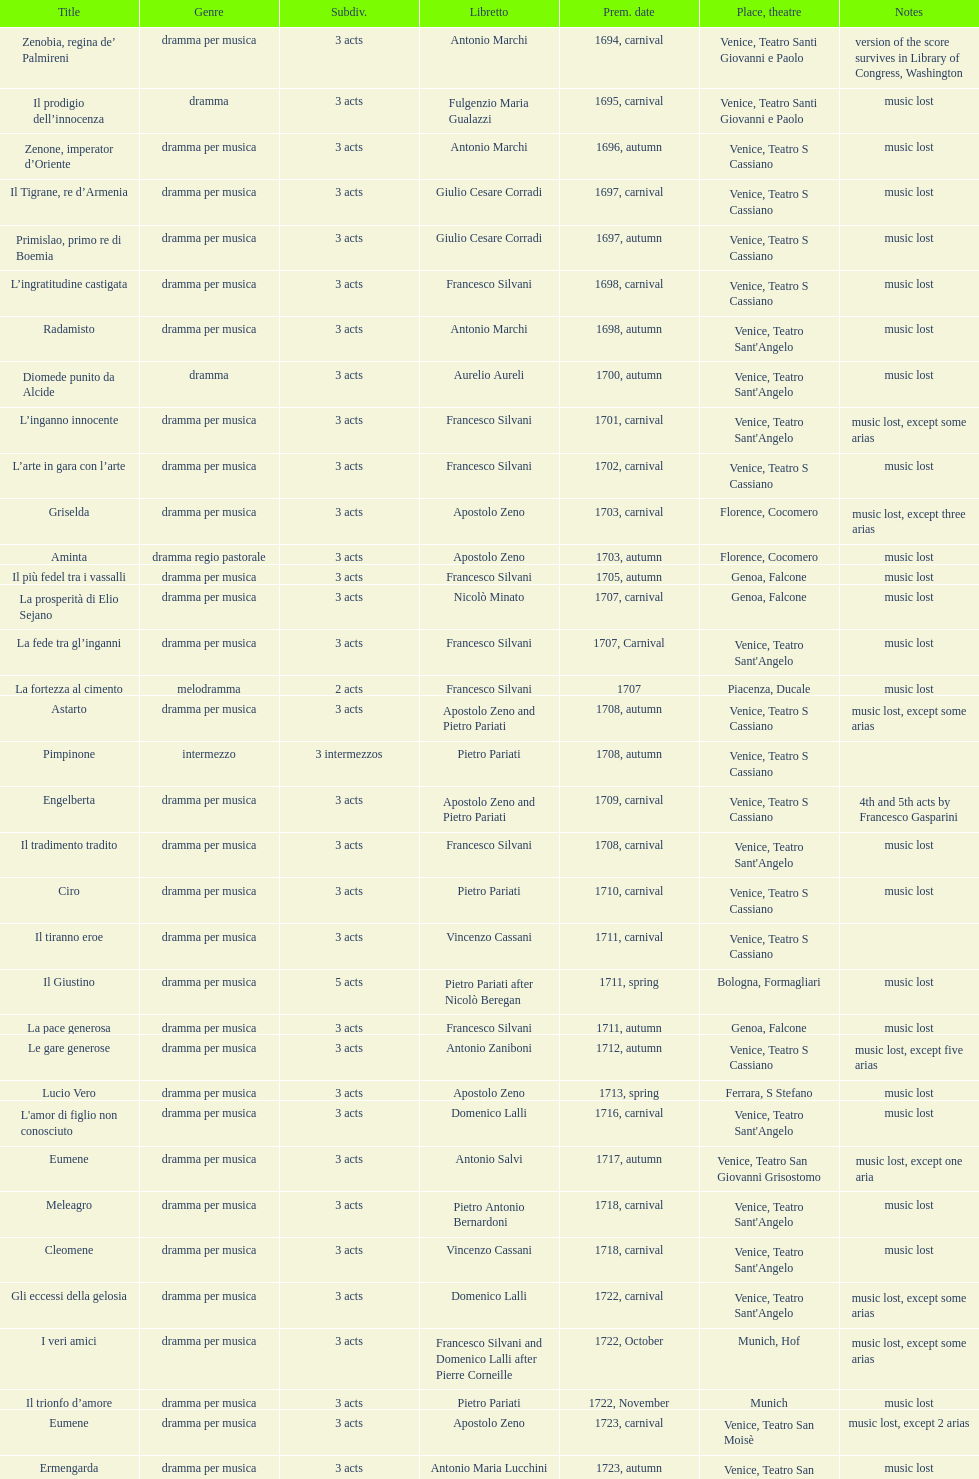Which opera has the most acts, la fortezza al cimento or astarto? Astarto. 